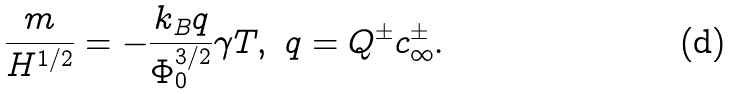Convert formula to latex. <formula><loc_0><loc_0><loc_500><loc_500>\frac { m } { H ^ { 1 / 2 } } = - \frac { k _ { B } q } { \Phi _ { 0 } ^ { 3 / 2 } } \gamma T , \text { } q = Q ^ { \pm } c _ { \infty } ^ { \pm } .</formula> 